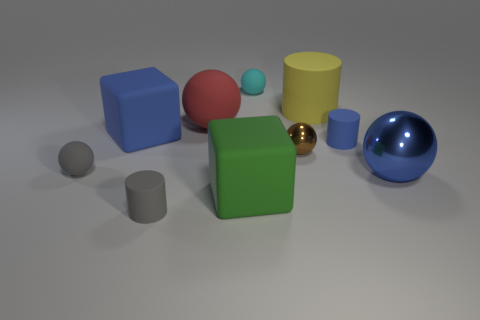How many things are tiny brown things that are on the left side of the big blue metal sphere or large blue things left of the cyan rubber object?
Offer a very short reply. 2. What is the color of the small object that is on the right side of the large yellow matte cylinder?
Provide a short and direct response. Blue. There is a matte block behind the tiny gray sphere; is there a ball that is on the right side of it?
Ensure brevity in your answer.  Yes. Are there fewer yellow objects than blocks?
Provide a succinct answer. Yes. What material is the big thing that is in front of the blue object in front of the brown shiny sphere?
Make the answer very short. Rubber. Is the size of the brown metal object the same as the cyan rubber thing?
Give a very brief answer. Yes. What number of objects are either gray rubber balls or blue matte things?
Give a very brief answer. 3. There is a matte object that is both behind the big matte sphere and to the right of the small cyan ball; how big is it?
Your answer should be very brief. Large. Are there fewer red rubber objects that are on the right side of the large blue metallic thing than small blue shiny spheres?
Your response must be concise. No. What is the shape of the tiny blue object that is the same material as the big yellow thing?
Your answer should be compact. Cylinder. 